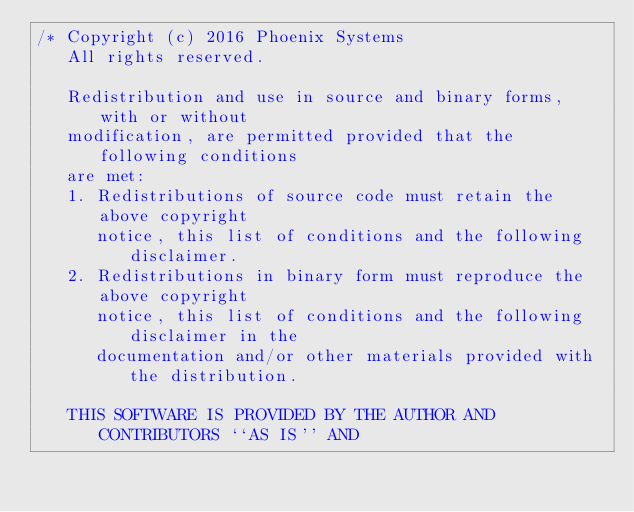<code> <loc_0><loc_0><loc_500><loc_500><_C_>/* Copyright (c) 2016 Phoenix Systems
   All rights reserved.

   Redistribution and use in source and binary forms, with or without
   modification, are permitted provided that the following conditions
   are met:
   1. Redistributions of source code must retain the above copyright
      notice, this list of conditions and the following disclaimer.
   2. Redistributions in binary form must reproduce the above copyright
      notice, this list of conditions and the following disclaimer in the
      documentation and/or other materials provided with the distribution.

   THIS SOFTWARE IS PROVIDED BY THE AUTHOR AND CONTRIBUTORS ``AS IS'' AND</code> 